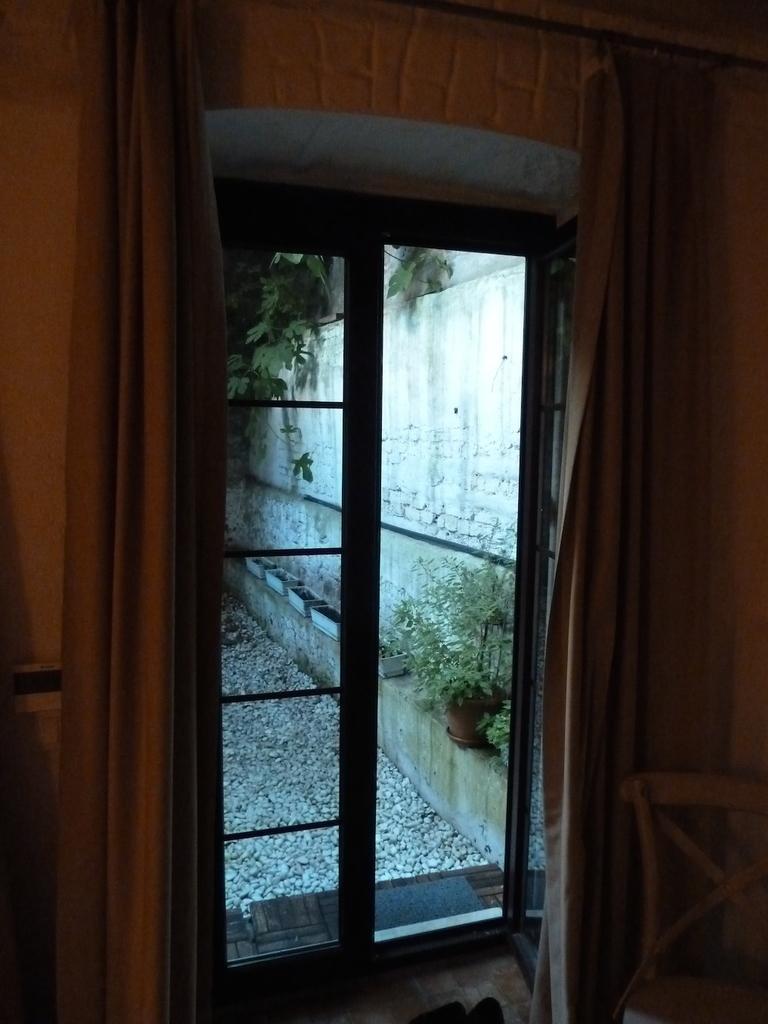Could you give a brief overview of what you see in this image? In this image, we can see the wall and some curtains. We can also see some doors and the ground. We can see some stones and some plants in a pot. We can also see a tree and a chair on the right. We can see some objects at the bottom. 